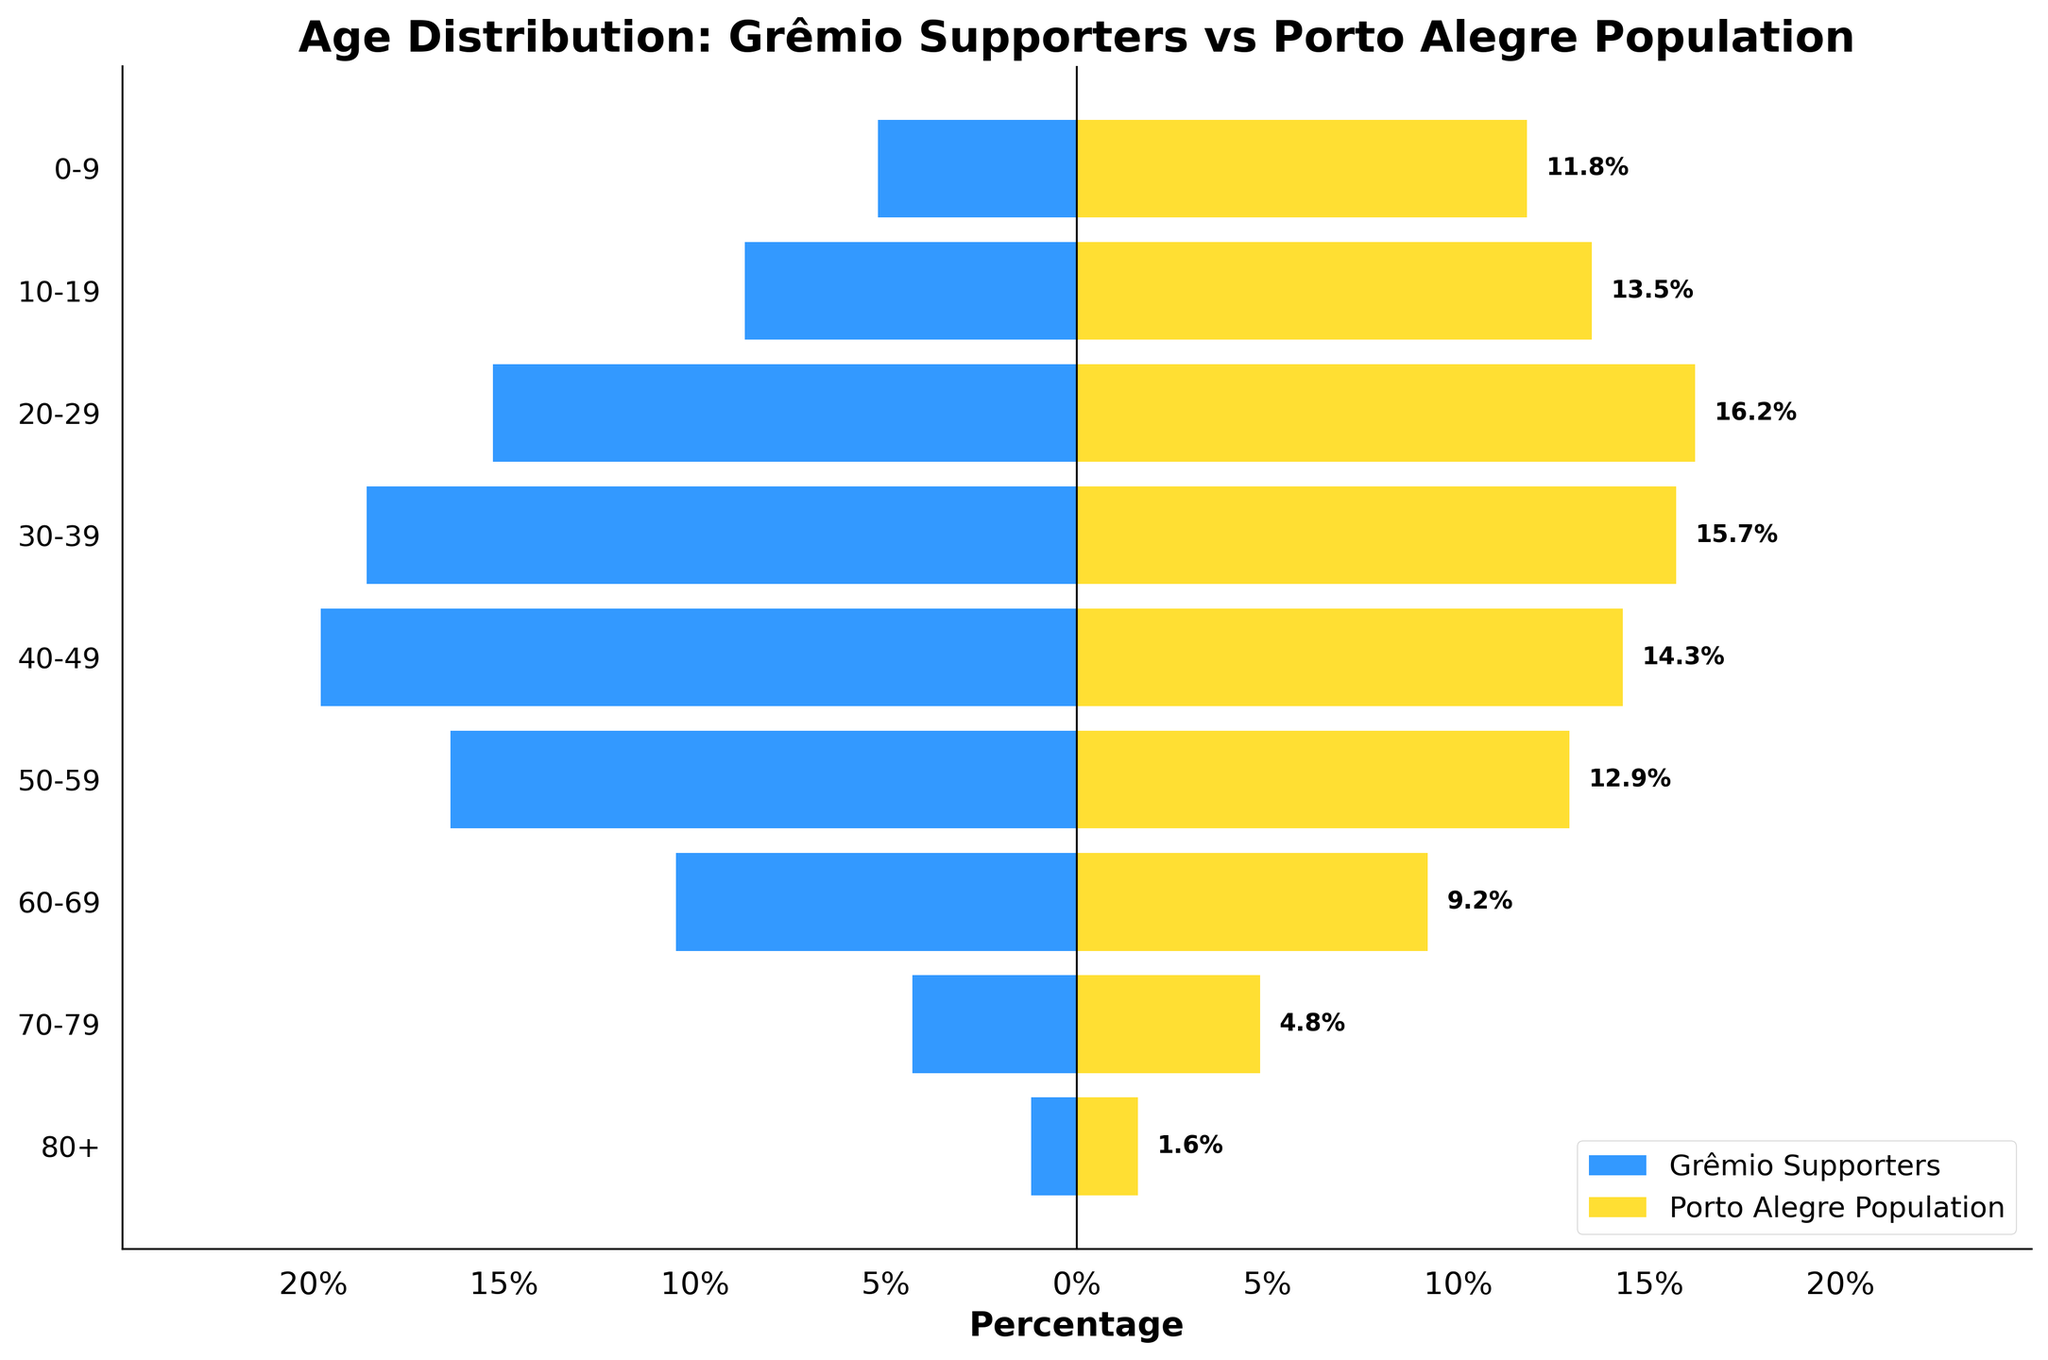What is the age group with the highest percentage of Grêmio supporters? When you look at the plotted bars on the left side (Grêmio supporters) of the pyramid, the longest bar is for the age group 40-49.
Answer: 40-49 Which age group has a higher percentage in the general population of Porto Alegre compared to Grêmio supporters? By comparing the lengths of the bars for Porto Alegre's general population to Grêmio supporters for each age group, the age groups 0-9, 10-19, and 70-79 have higher percentages in the general population. Let's take the age group 10-19 as an example of one of these groups.
Answer: 10-19 What is the difference in percentage between Grêmio supporters and the Porto Alegre population for the age group 60-69? To find the difference, subtract the percentage of the Porto Alegre population from the percentage of Grêmio supporters for the age group 60-69. Both percentages are 10.5% for Grêmio supporters and 9.2% for Porto Alegre. 10.5% - 9.2% = 1.3%.
Answer: 1.3% Which side of the Population Pyramid chart corresponds to Grêmio supporters? The left side of the Population Pyramid (the axis with negative values) represents Grêmio supporters, as indicated by the blue bars and the label.
Answer: Left What is the total percentage of Grêmio supporters in the age groups 30-39 and 40-49? Sum the percentages for the age groups 30-39 and 40-49. 18.6% (30-39) + 19.8% (40-49) = 38.4%.
Answer: 38.4% How does the percentage of Grêmio supporters aged 20-29 compare to the same age group in the general population of Porto Alegre? By comparing the values for the age group 20-29, Grêmio supporters have a percentage of 15.3%, while Porto Alegre has 16.2%. Thus, Porto Alegre's percentage is higher.
Answer: Porto Alegre's is higher Which age group has the smallest difference in percentage between Grêmio supporters and the Porto Alegre population? By comparing the percentage differences for each age group, the smallest difference is found in the age group 70-79, where Grêmio supporters are 4.3% and the Porto Alegre population is 4.8%. The difference is 0.5%.
Answer: 70-79 What percentage of the Grêmio supporters are aged 50-59? Refer to the plotted bar for the Grêmio supporters in the 50-59 age group, which shows a percentage of 16.4%.
Answer: 16.4% What trend do you observe about the percentage of Grêmio supporters compared to the general population across different age groups? Observing the chart, Grêmio supporters tend to have a higher percentage in middle age groups (30-49) compared to the general population, while younger (0-19) and older (70+) groups have lower percentages of Grêmio supporters.
Answer: Higher in 30-49, lower in 0-19 and 70+ Of the age groups displayed, which has the smallest percentage for both Grêmio supporters and the Porto Alegre population? By looking at both sets of bars, the age group 80+ has the smallest percentage for both Grêmio supporters (1.2%) and the Porto Alegre population (1.6%).
Answer: 80+ 